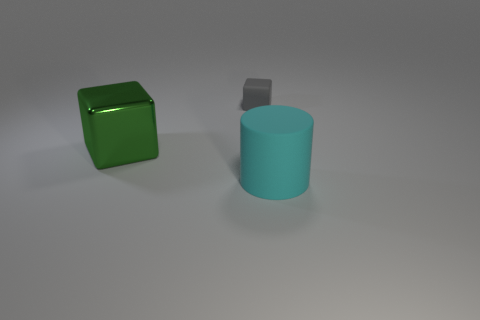Add 1 small rubber cubes. How many objects exist? 4 Subtract all cubes. How many objects are left? 1 Subtract all gray cylinders. Subtract all blue spheres. How many cylinders are left? 1 Subtract all yellow cubes. How many green cylinders are left? 0 Subtract all big gray metal cylinders. Subtract all gray rubber blocks. How many objects are left? 2 Add 1 large objects. How many large objects are left? 3 Add 2 cyan cylinders. How many cyan cylinders exist? 3 Subtract 0 yellow balls. How many objects are left? 3 Subtract 1 cubes. How many cubes are left? 1 